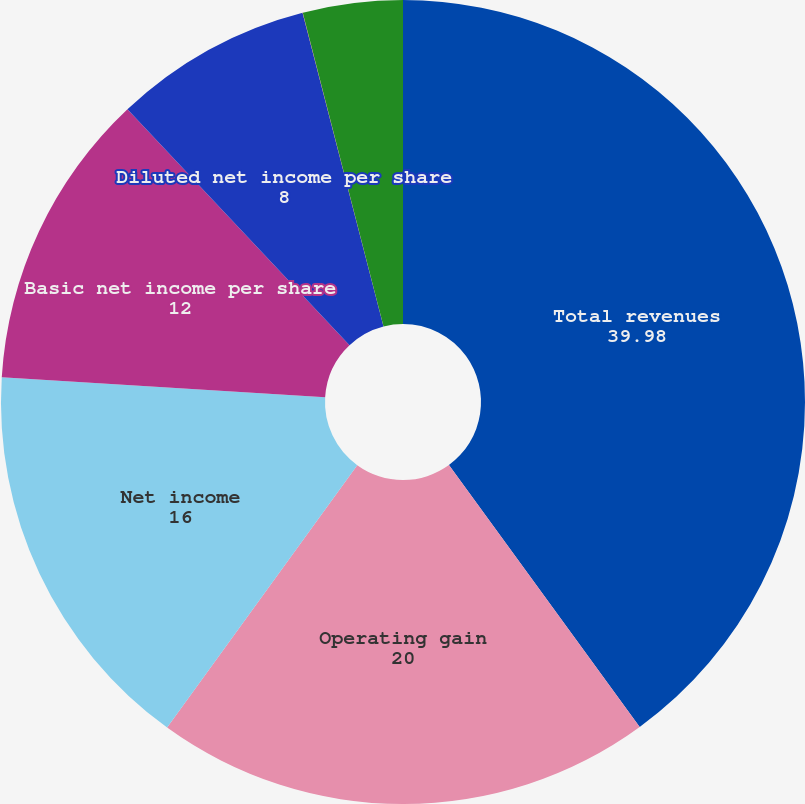Convert chart to OTSL. <chart><loc_0><loc_0><loc_500><loc_500><pie_chart><fcel>Total revenues<fcel>Operating gain<fcel>Net income<fcel>Basic net income per share<fcel>Diluted net income per share<fcel>Pro forma basic earnings per<fcel>Pro forma diluted earnings per<nl><fcel>39.98%<fcel>20.0%<fcel>16.0%<fcel>12.0%<fcel>8.0%<fcel>0.01%<fcel>4.01%<nl></chart> 